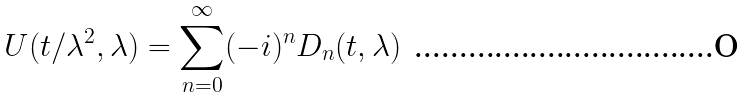Convert formula to latex. <formula><loc_0><loc_0><loc_500><loc_500>U ( t / \lambda ^ { 2 } , \lambda ) = \sum _ { n = 0 } ^ { \infty } ( - i ) ^ { n } D _ { n } ( t , \lambda )</formula> 